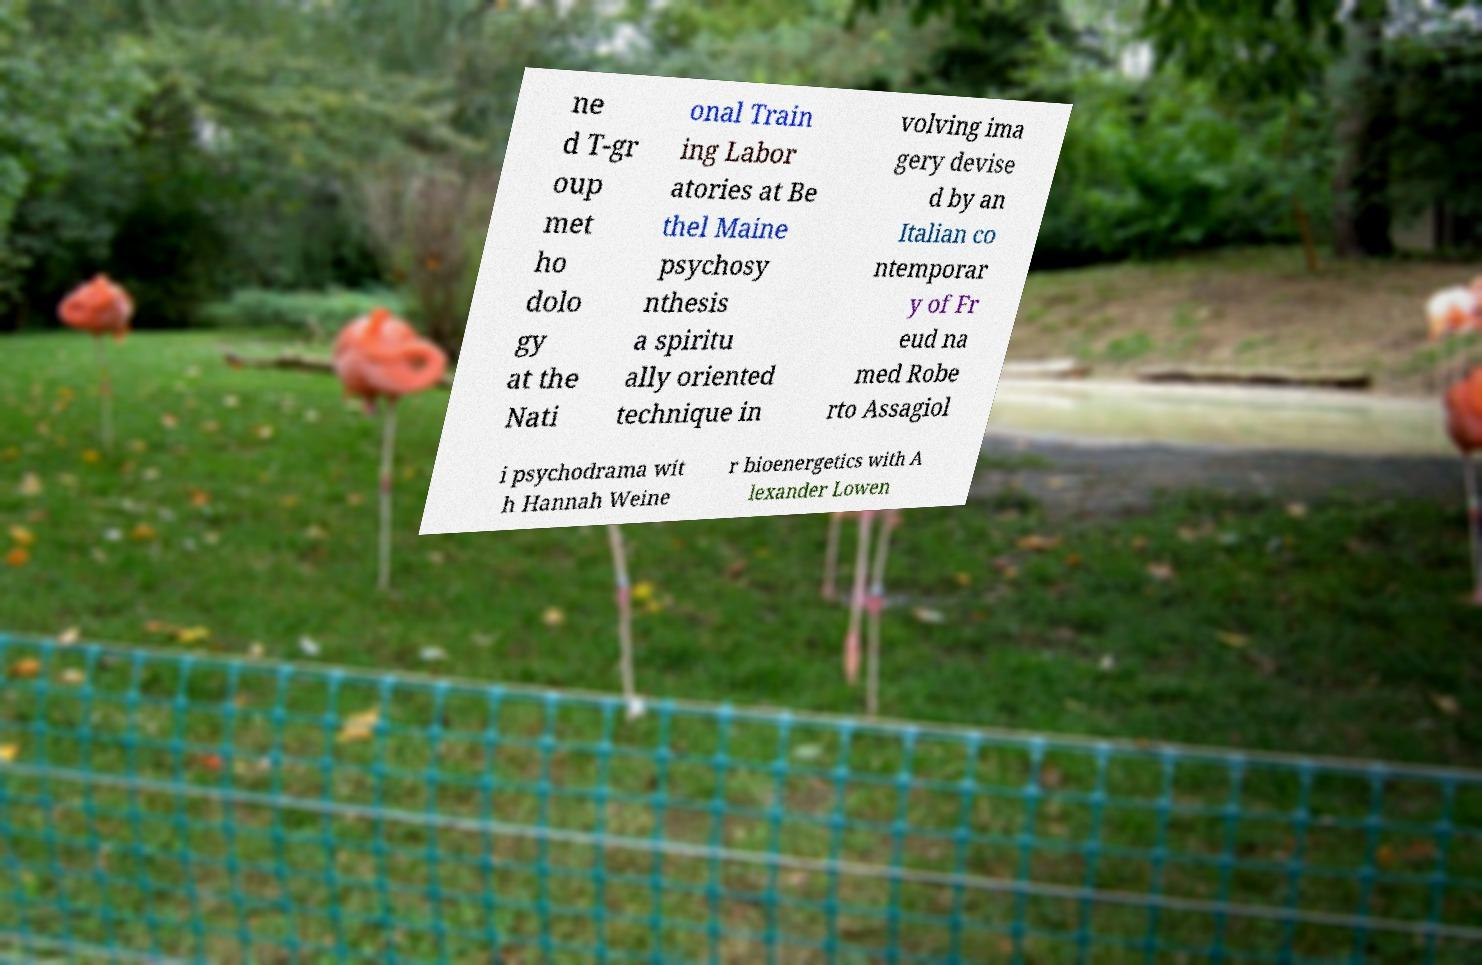What messages or text are displayed in this image? I need them in a readable, typed format. ne d T-gr oup met ho dolo gy at the Nati onal Train ing Labor atories at Be thel Maine psychosy nthesis a spiritu ally oriented technique in volving ima gery devise d by an Italian co ntemporar y of Fr eud na med Robe rto Assagiol i psychodrama wit h Hannah Weine r bioenergetics with A lexander Lowen 